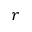Convert formula to latex. <formula><loc_0><loc_0><loc_500><loc_500>r</formula> 